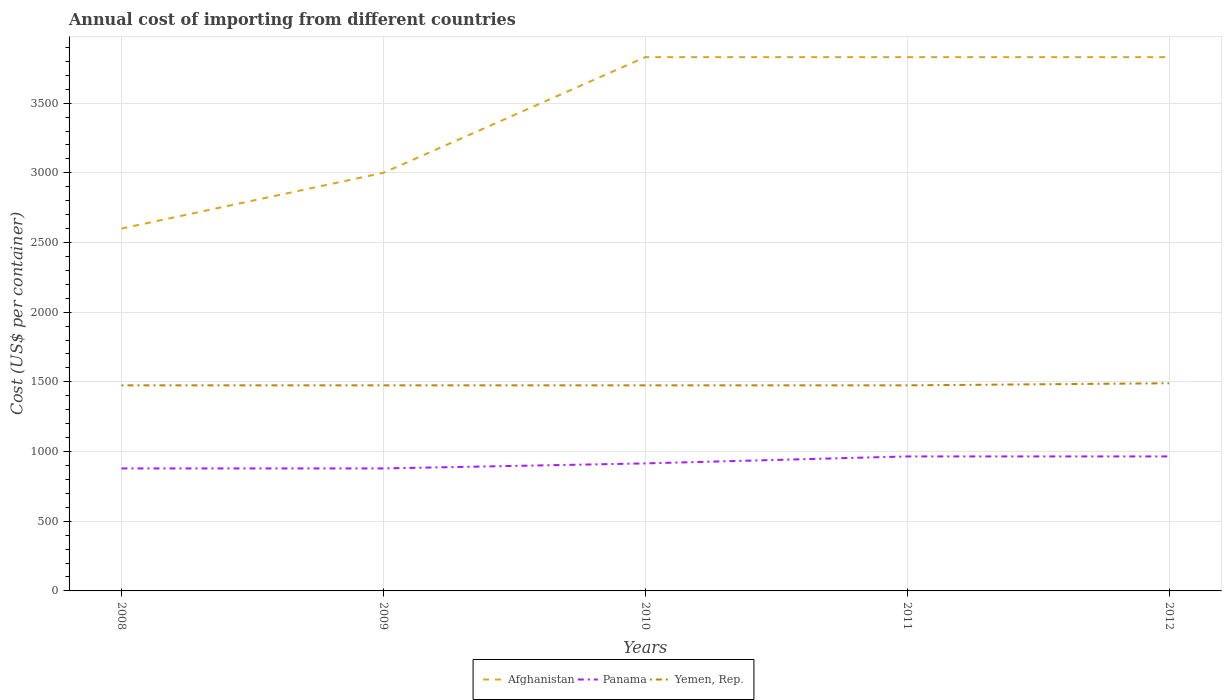Does the line corresponding to Yemen, Rep. intersect with the line corresponding to Afghanistan?
Offer a terse response. No. Across all years, what is the maximum total annual cost of importing in Panama?
Ensure brevity in your answer.  879. What is the total total annual cost of importing in Afghanistan in the graph?
Ensure brevity in your answer.  -1230. What is the difference between the highest and the second highest total annual cost of importing in Yemen, Rep.?
Provide a succinct answer. 15. Is the total annual cost of importing in Panama strictly greater than the total annual cost of importing in Afghanistan over the years?
Your response must be concise. Yes. How many lines are there?
Offer a terse response. 3. How many years are there in the graph?
Your answer should be compact. 5. What is the difference between two consecutive major ticks on the Y-axis?
Make the answer very short. 500. Are the values on the major ticks of Y-axis written in scientific E-notation?
Your answer should be very brief. No. Does the graph contain any zero values?
Offer a very short reply. No. Does the graph contain grids?
Ensure brevity in your answer.  Yes. Where does the legend appear in the graph?
Ensure brevity in your answer.  Bottom center. How many legend labels are there?
Keep it short and to the point. 3. What is the title of the graph?
Your answer should be very brief. Annual cost of importing from different countries. Does "Czech Republic" appear as one of the legend labels in the graph?
Give a very brief answer. No. What is the label or title of the Y-axis?
Your answer should be very brief. Cost (US$ per container). What is the Cost (US$ per container) of Afghanistan in 2008?
Ensure brevity in your answer.  2600. What is the Cost (US$ per container) in Panama in 2008?
Offer a terse response. 879. What is the Cost (US$ per container) in Yemen, Rep. in 2008?
Your response must be concise. 1475. What is the Cost (US$ per container) in Afghanistan in 2009?
Provide a short and direct response. 3000. What is the Cost (US$ per container) in Panama in 2009?
Make the answer very short. 879. What is the Cost (US$ per container) of Yemen, Rep. in 2009?
Give a very brief answer. 1475. What is the Cost (US$ per container) of Afghanistan in 2010?
Offer a terse response. 3830. What is the Cost (US$ per container) in Panama in 2010?
Offer a terse response. 915. What is the Cost (US$ per container) of Yemen, Rep. in 2010?
Offer a very short reply. 1475. What is the Cost (US$ per container) in Afghanistan in 2011?
Ensure brevity in your answer.  3830. What is the Cost (US$ per container) of Panama in 2011?
Offer a terse response. 965. What is the Cost (US$ per container) in Yemen, Rep. in 2011?
Make the answer very short. 1475. What is the Cost (US$ per container) in Afghanistan in 2012?
Offer a very short reply. 3830. What is the Cost (US$ per container) of Panama in 2012?
Provide a short and direct response. 965. What is the Cost (US$ per container) in Yemen, Rep. in 2012?
Provide a succinct answer. 1490. Across all years, what is the maximum Cost (US$ per container) in Afghanistan?
Ensure brevity in your answer.  3830. Across all years, what is the maximum Cost (US$ per container) in Panama?
Give a very brief answer. 965. Across all years, what is the maximum Cost (US$ per container) of Yemen, Rep.?
Give a very brief answer. 1490. Across all years, what is the minimum Cost (US$ per container) in Afghanistan?
Offer a very short reply. 2600. Across all years, what is the minimum Cost (US$ per container) in Panama?
Give a very brief answer. 879. Across all years, what is the minimum Cost (US$ per container) in Yemen, Rep.?
Your response must be concise. 1475. What is the total Cost (US$ per container) of Afghanistan in the graph?
Offer a terse response. 1.71e+04. What is the total Cost (US$ per container) of Panama in the graph?
Your response must be concise. 4603. What is the total Cost (US$ per container) of Yemen, Rep. in the graph?
Your response must be concise. 7390. What is the difference between the Cost (US$ per container) in Afghanistan in 2008 and that in 2009?
Your response must be concise. -400. What is the difference between the Cost (US$ per container) in Afghanistan in 2008 and that in 2010?
Your answer should be compact. -1230. What is the difference between the Cost (US$ per container) of Panama in 2008 and that in 2010?
Your answer should be compact. -36. What is the difference between the Cost (US$ per container) of Afghanistan in 2008 and that in 2011?
Provide a short and direct response. -1230. What is the difference between the Cost (US$ per container) in Panama in 2008 and that in 2011?
Your answer should be very brief. -86. What is the difference between the Cost (US$ per container) of Afghanistan in 2008 and that in 2012?
Your answer should be very brief. -1230. What is the difference between the Cost (US$ per container) in Panama in 2008 and that in 2012?
Give a very brief answer. -86. What is the difference between the Cost (US$ per container) in Yemen, Rep. in 2008 and that in 2012?
Provide a short and direct response. -15. What is the difference between the Cost (US$ per container) of Afghanistan in 2009 and that in 2010?
Ensure brevity in your answer.  -830. What is the difference between the Cost (US$ per container) of Panama in 2009 and that in 2010?
Provide a succinct answer. -36. What is the difference between the Cost (US$ per container) in Yemen, Rep. in 2009 and that in 2010?
Give a very brief answer. 0. What is the difference between the Cost (US$ per container) in Afghanistan in 2009 and that in 2011?
Offer a very short reply. -830. What is the difference between the Cost (US$ per container) in Panama in 2009 and that in 2011?
Your response must be concise. -86. What is the difference between the Cost (US$ per container) of Yemen, Rep. in 2009 and that in 2011?
Offer a terse response. 0. What is the difference between the Cost (US$ per container) in Afghanistan in 2009 and that in 2012?
Offer a terse response. -830. What is the difference between the Cost (US$ per container) of Panama in 2009 and that in 2012?
Your answer should be very brief. -86. What is the difference between the Cost (US$ per container) in Yemen, Rep. in 2009 and that in 2012?
Offer a terse response. -15. What is the difference between the Cost (US$ per container) in Afghanistan in 2010 and that in 2012?
Your answer should be compact. 0. What is the difference between the Cost (US$ per container) in Panama in 2011 and that in 2012?
Keep it short and to the point. 0. What is the difference between the Cost (US$ per container) in Yemen, Rep. in 2011 and that in 2012?
Ensure brevity in your answer.  -15. What is the difference between the Cost (US$ per container) in Afghanistan in 2008 and the Cost (US$ per container) in Panama in 2009?
Offer a very short reply. 1721. What is the difference between the Cost (US$ per container) in Afghanistan in 2008 and the Cost (US$ per container) in Yemen, Rep. in 2009?
Your answer should be compact. 1125. What is the difference between the Cost (US$ per container) of Panama in 2008 and the Cost (US$ per container) of Yemen, Rep. in 2009?
Ensure brevity in your answer.  -596. What is the difference between the Cost (US$ per container) of Afghanistan in 2008 and the Cost (US$ per container) of Panama in 2010?
Your answer should be compact. 1685. What is the difference between the Cost (US$ per container) of Afghanistan in 2008 and the Cost (US$ per container) of Yemen, Rep. in 2010?
Give a very brief answer. 1125. What is the difference between the Cost (US$ per container) of Panama in 2008 and the Cost (US$ per container) of Yemen, Rep. in 2010?
Ensure brevity in your answer.  -596. What is the difference between the Cost (US$ per container) of Afghanistan in 2008 and the Cost (US$ per container) of Panama in 2011?
Your answer should be compact. 1635. What is the difference between the Cost (US$ per container) of Afghanistan in 2008 and the Cost (US$ per container) of Yemen, Rep. in 2011?
Give a very brief answer. 1125. What is the difference between the Cost (US$ per container) in Panama in 2008 and the Cost (US$ per container) in Yemen, Rep. in 2011?
Your answer should be very brief. -596. What is the difference between the Cost (US$ per container) in Afghanistan in 2008 and the Cost (US$ per container) in Panama in 2012?
Your answer should be compact. 1635. What is the difference between the Cost (US$ per container) in Afghanistan in 2008 and the Cost (US$ per container) in Yemen, Rep. in 2012?
Make the answer very short. 1110. What is the difference between the Cost (US$ per container) in Panama in 2008 and the Cost (US$ per container) in Yemen, Rep. in 2012?
Keep it short and to the point. -611. What is the difference between the Cost (US$ per container) in Afghanistan in 2009 and the Cost (US$ per container) in Panama in 2010?
Keep it short and to the point. 2085. What is the difference between the Cost (US$ per container) of Afghanistan in 2009 and the Cost (US$ per container) of Yemen, Rep. in 2010?
Make the answer very short. 1525. What is the difference between the Cost (US$ per container) in Panama in 2009 and the Cost (US$ per container) in Yemen, Rep. in 2010?
Keep it short and to the point. -596. What is the difference between the Cost (US$ per container) in Afghanistan in 2009 and the Cost (US$ per container) in Panama in 2011?
Offer a terse response. 2035. What is the difference between the Cost (US$ per container) in Afghanistan in 2009 and the Cost (US$ per container) in Yemen, Rep. in 2011?
Provide a succinct answer. 1525. What is the difference between the Cost (US$ per container) in Panama in 2009 and the Cost (US$ per container) in Yemen, Rep. in 2011?
Offer a terse response. -596. What is the difference between the Cost (US$ per container) in Afghanistan in 2009 and the Cost (US$ per container) in Panama in 2012?
Provide a short and direct response. 2035. What is the difference between the Cost (US$ per container) in Afghanistan in 2009 and the Cost (US$ per container) in Yemen, Rep. in 2012?
Your response must be concise. 1510. What is the difference between the Cost (US$ per container) of Panama in 2009 and the Cost (US$ per container) of Yemen, Rep. in 2012?
Offer a terse response. -611. What is the difference between the Cost (US$ per container) of Afghanistan in 2010 and the Cost (US$ per container) of Panama in 2011?
Provide a short and direct response. 2865. What is the difference between the Cost (US$ per container) of Afghanistan in 2010 and the Cost (US$ per container) of Yemen, Rep. in 2011?
Make the answer very short. 2355. What is the difference between the Cost (US$ per container) of Panama in 2010 and the Cost (US$ per container) of Yemen, Rep. in 2011?
Your answer should be very brief. -560. What is the difference between the Cost (US$ per container) of Afghanistan in 2010 and the Cost (US$ per container) of Panama in 2012?
Make the answer very short. 2865. What is the difference between the Cost (US$ per container) in Afghanistan in 2010 and the Cost (US$ per container) in Yemen, Rep. in 2012?
Keep it short and to the point. 2340. What is the difference between the Cost (US$ per container) in Panama in 2010 and the Cost (US$ per container) in Yemen, Rep. in 2012?
Provide a short and direct response. -575. What is the difference between the Cost (US$ per container) of Afghanistan in 2011 and the Cost (US$ per container) of Panama in 2012?
Give a very brief answer. 2865. What is the difference between the Cost (US$ per container) in Afghanistan in 2011 and the Cost (US$ per container) in Yemen, Rep. in 2012?
Provide a short and direct response. 2340. What is the difference between the Cost (US$ per container) in Panama in 2011 and the Cost (US$ per container) in Yemen, Rep. in 2012?
Your response must be concise. -525. What is the average Cost (US$ per container) in Afghanistan per year?
Offer a very short reply. 3418. What is the average Cost (US$ per container) of Panama per year?
Your response must be concise. 920.6. What is the average Cost (US$ per container) in Yemen, Rep. per year?
Offer a very short reply. 1478. In the year 2008, what is the difference between the Cost (US$ per container) of Afghanistan and Cost (US$ per container) of Panama?
Provide a short and direct response. 1721. In the year 2008, what is the difference between the Cost (US$ per container) of Afghanistan and Cost (US$ per container) of Yemen, Rep.?
Provide a succinct answer. 1125. In the year 2008, what is the difference between the Cost (US$ per container) in Panama and Cost (US$ per container) in Yemen, Rep.?
Give a very brief answer. -596. In the year 2009, what is the difference between the Cost (US$ per container) of Afghanistan and Cost (US$ per container) of Panama?
Ensure brevity in your answer.  2121. In the year 2009, what is the difference between the Cost (US$ per container) of Afghanistan and Cost (US$ per container) of Yemen, Rep.?
Offer a very short reply. 1525. In the year 2009, what is the difference between the Cost (US$ per container) of Panama and Cost (US$ per container) of Yemen, Rep.?
Your answer should be very brief. -596. In the year 2010, what is the difference between the Cost (US$ per container) in Afghanistan and Cost (US$ per container) in Panama?
Keep it short and to the point. 2915. In the year 2010, what is the difference between the Cost (US$ per container) of Afghanistan and Cost (US$ per container) of Yemen, Rep.?
Keep it short and to the point. 2355. In the year 2010, what is the difference between the Cost (US$ per container) in Panama and Cost (US$ per container) in Yemen, Rep.?
Keep it short and to the point. -560. In the year 2011, what is the difference between the Cost (US$ per container) of Afghanistan and Cost (US$ per container) of Panama?
Offer a terse response. 2865. In the year 2011, what is the difference between the Cost (US$ per container) in Afghanistan and Cost (US$ per container) in Yemen, Rep.?
Provide a succinct answer. 2355. In the year 2011, what is the difference between the Cost (US$ per container) in Panama and Cost (US$ per container) in Yemen, Rep.?
Your response must be concise. -510. In the year 2012, what is the difference between the Cost (US$ per container) in Afghanistan and Cost (US$ per container) in Panama?
Give a very brief answer. 2865. In the year 2012, what is the difference between the Cost (US$ per container) in Afghanistan and Cost (US$ per container) in Yemen, Rep.?
Your answer should be compact. 2340. In the year 2012, what is the difference between the Cost (US$ per container) in Panama and Cost (US$ per container) in Yemen, Rep.?
Offer a very short reply. -525. What is the ratio of the Cost (US$ per container) of Afghanistan in 2008 to that in 2009?
Give a very brief answer. 0.87. What is the ratio of the Cost (US$ per container) of Afghanistan in 2008 to that in 2010?
Offer a very short reply. 0.68. What is the ratio of the Cost (US$ per container) in Panama in 2008 to that in 2010?
Keep it short and to the point. 0.96. What is the ratio of the Cost (US$ per container) of Yemen, Rep. in 2008 to that in 2010?
Provide a succinct answer. 1. What is the ratio of the Cost (US$ per container) in Afghanistan in 2008 to that in 2011?
Provide a short and direct response. 0.68. What is the ratio of the Cost (US$ per container) of Panama in 2008 to that in 2011?
Offer a terse response. 0.91. What is the ratio of the Cost (US$ per container) of Afghanistan in 2008 to that in 2012?
Ensure brevity in your answer.  0.68. What is the ratio of the Cost (US$ per container) in Panama in 2008 to that in 2012?
Make the answer very short. 0.91. What is the ratio of the Cost (US$ per container) of Yemen, Rep. in 2008 to that in 2012?
Offer a very short reply. 0.99. What is the ratio of the Cost (US$ per container) of Afghanistan in 2009 to that in 2010?
Give a very brief answer. 0.78. What is the ratio of the Cost (US$ per container) of Panama in 2009 to that in 2010?
Provide a succinct answer. 0.96. What is the ratio of the Cost (US$ per container) in Afghanistan in 2009 to that in 2011?
Make the answer very short. 0.78. What is the ratio of the Cost (US$ per container) of Panama in 2009 to that in 2011?
Make the answer very short. 0.91. What is the ratio of the Cost (US$ per container) in Yemen, Rep. in 2009 to that in 2011?
Offer a terse response. 1. What is the ratio of the Cost (US$ per container) in Afghanistan in 2009 to that in 2012?
Give a very brief answer. 0.78. What is the ratio of the Cost (US$ per container) of Panama in 2009 to that in 2012?
Ensure brevity in your answer.  0.91. What is the ratio of the Cost (US$ per container) of Panama in 2010 to that in 2011?
Your answer should be compact. 0.95. What is the ratio of the Cost (US$ per container) of Yemen, Rep. in 2010 to that in 2011?
Your answer should be very brief. 1. What is the ratio of the Cost (US$ per container) of Afghanistan in 2010 to that in 2012?
Keep it short and to the point. 1. What is the ratio of the Cost (US$ per container) in Panama in 2010 to that in 2012?
Keep it short and to the point. 0.95. What is the ratio of the Cost (US$ per container) of Afghanistan in 2011 to that in 2012?
Your answer should be compact. 1. What is the ratio of the Cost (US$ per container) in Panama in 2011 to that in 2012?
Your response must be concise. 1. What is the difference between the highest and the second highest Cost (US$ per container) in Afghanistan?
Provide a succinct answer. 0. What is the difference between the highest and the second highest Cost (US$ per container) of Panama?
Give a very brief answer. 0. What is the difference between the highest and the lowest Cost (US$ per container) of Afghanistan?
Provide a short and direct response. 1230. What is the difference between the highest and the lowest Cost (US$ per container) of Panama?
Offer a terse response. 86. 